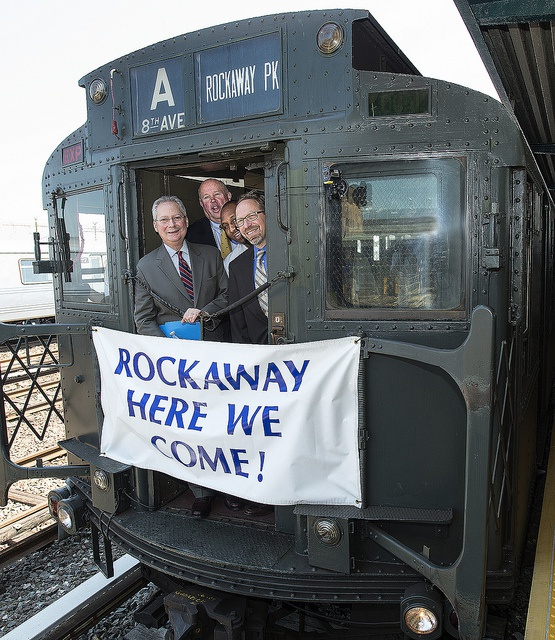Describe the objects in this image and their specific colors. I can see train in black, gray, white, lightgray, and darkgray tones, people in white, gray, black, pink, and darkgray tones, people in white, black, gray, pink, and darkgray tones, people in white, black, gray, and lightpink tones, and people in white, brown, gray, black, and darkgray tones in this image. 